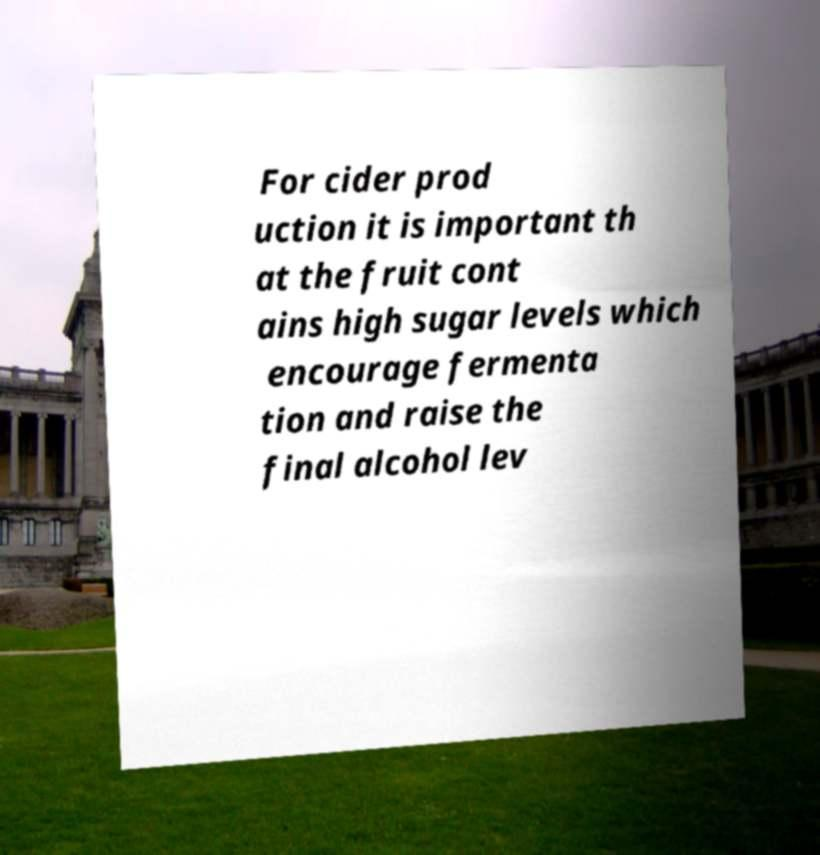Could you assist in decoding the text presented in this image and type it out clearly? For cider prod uction it is important th at the fruit cont ains high sugar levels which encourage fermenta tion and raise the final alcohol lev 